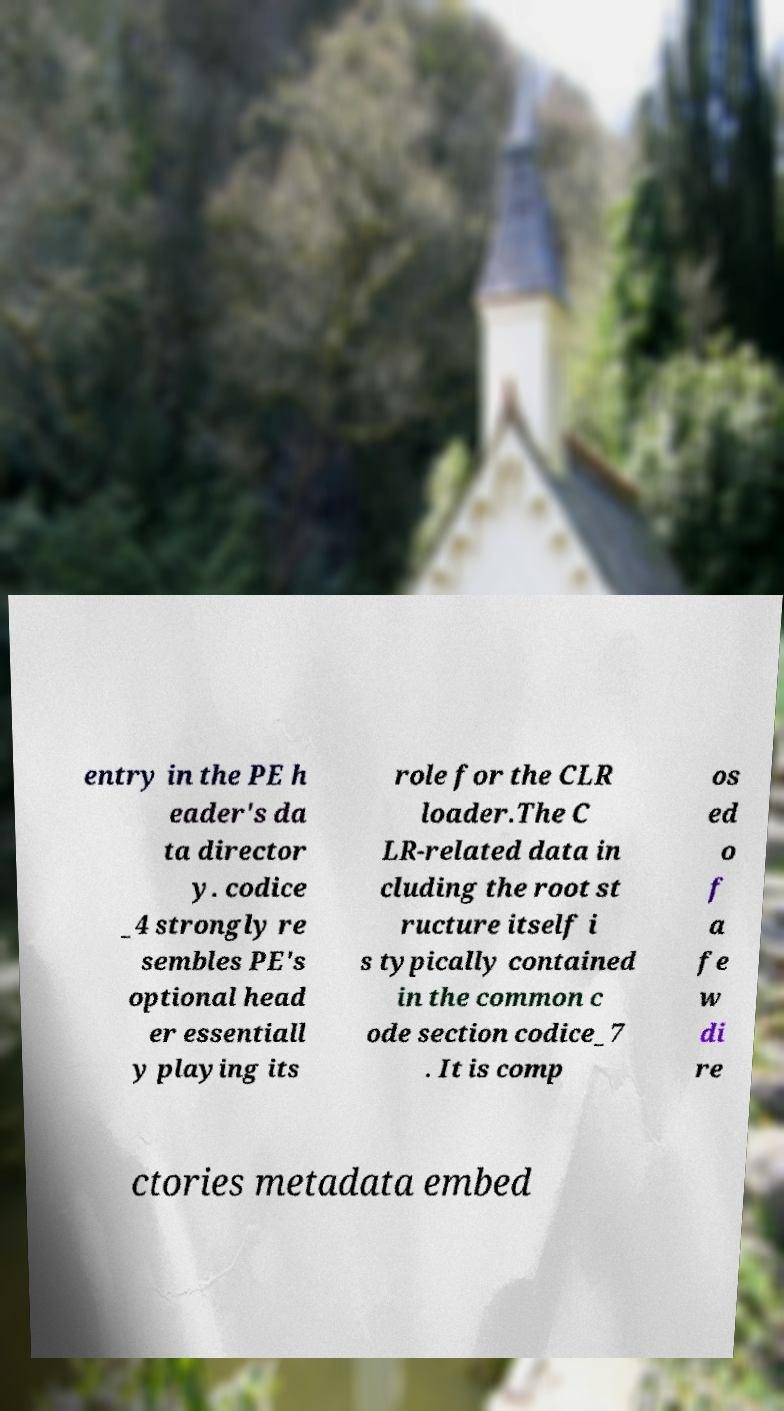For documentation purposes, I need the text within this image transcribed. Could you provide that? entry in the PE h eader's da ta director y. codice _4 strongly re sembles PE's optional head er essentiall y playing its role for the CLR loader.The C LR-related data in cluding the root st ructure itself i s typically contained in the common c ode section codice_7 . It is comp os ed o f a fe w di re ctories metadata embed 